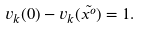Convert formula to latex. <formula><loc_0><loc_0><loc_500><loc_500>v _ { k } ( 0 ) - v _ { k } ( \tilde { x ^ { o } } ) = 1 .</formula> 